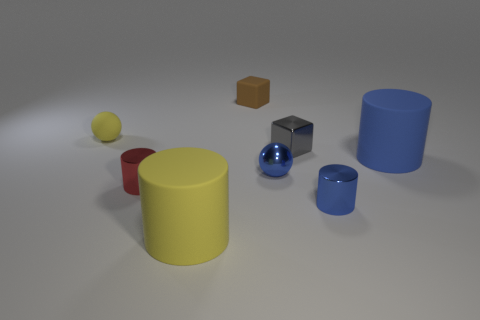What material is the sphere on the left side of the metallic object that is on the left side of the small brown block?
Your answer should be very brief. Rubber. There is a object that is behind the yellow matte object behind the red thing on the left side of the big blue rubber cylinder; what color is it?
Your response must be concise. Brown. What number of blue metal objects have the same size as the yellow matte sphere?
Your answer should be compact. 2. Are there more gray things that are in front of the small yellow rubber ball than metal things in front of the yellow cylinder?
Keep it short and to the point. Yes. The large matte cylinder behind the red cylinder that is in front of the small gray metal block is what color?
Your answer should be very brief. Blue. Are the yellow cylinder and the small blue cylinder made of the same material?
Provide a succinct answer. No. Is there another object of the same shape as the red thing?
Give a very brief answer. Yes. Does the metal cylinder that is to the left of the small gray block have the same color as the tiny rubber ball?
Ensure brevity in your answer.  No. Does the yellow matte object in front of the shiny block have the same size as the metallic cylinder that is on the left side of the brown rubber block?
Keep it short and to the point. No. What size is the yellow sphere that is made of the same material as the tiny brown block?
Ensure brevity in your answer.  Small. 